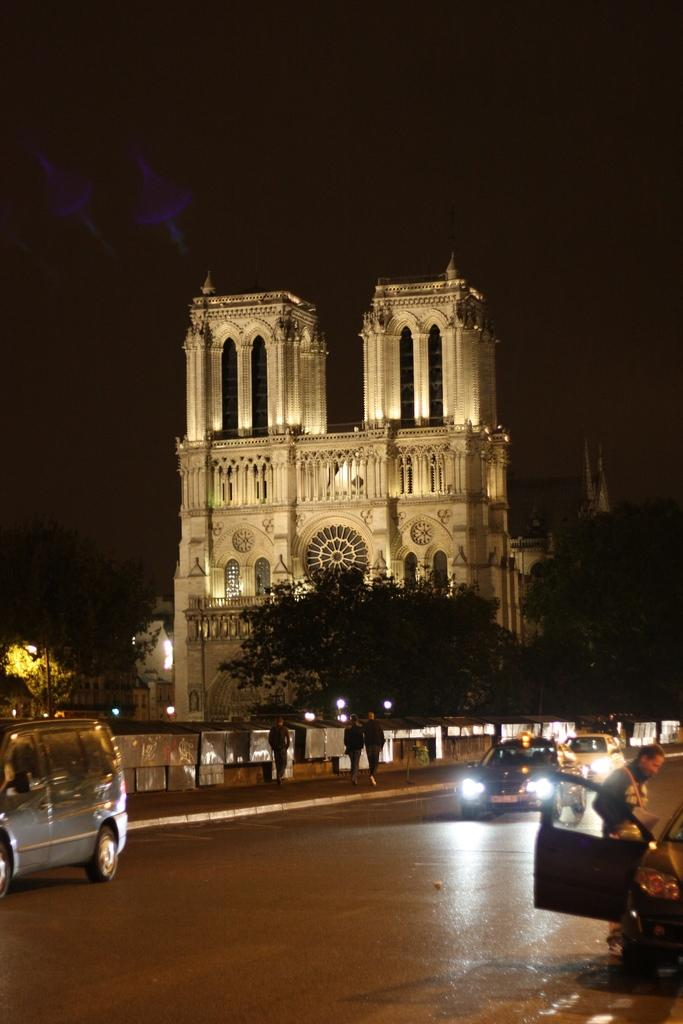What type of structure is visible in the image? There is a building in the image. What natural elements can be seen in the image? There are trees in the image. What mode of transportation can be observed on the road? Vehicles are present on the road in the image. What activity are people engaged in on the footpath? People are walking on the footpath in the image. Can you see a flock of birds flying over the building in the image? There is no mention of birds or a flock in the image, so we cannot confirm their presence. 